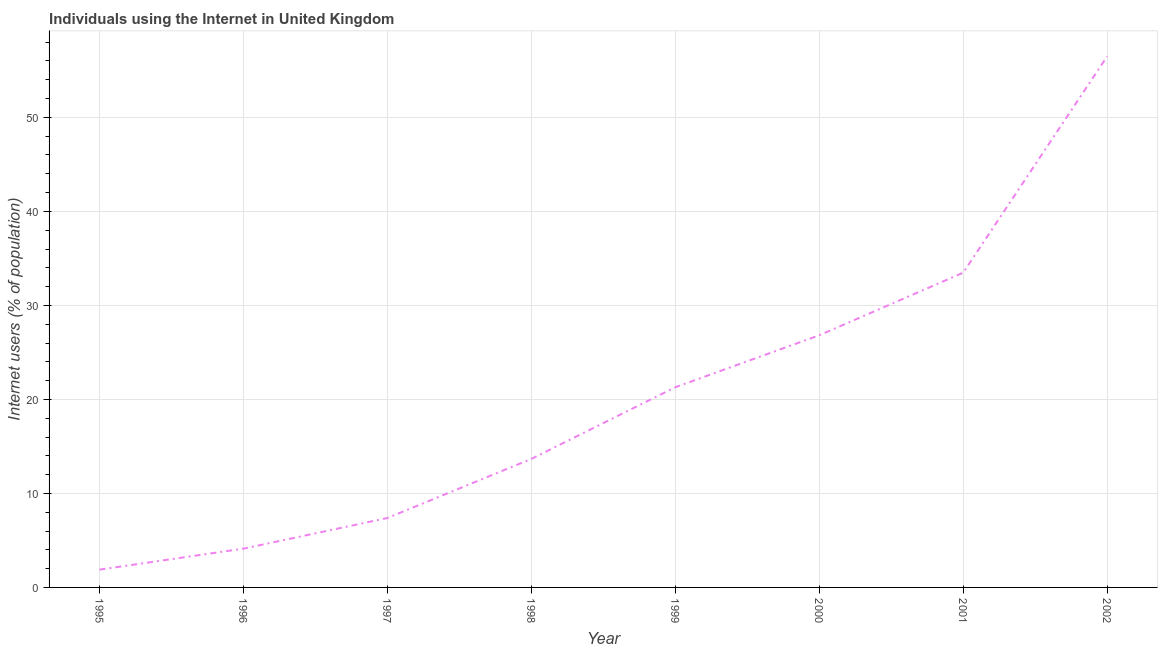What is the number of internet users in 1997?
Provide a succinct answer. 7.39. Across all years, what is the maximum number of internet users?
Give a very brief answer. 56.48. Across all years, what is the minimum number of internet users?
Keep it short and to the point. 1.9. In which year was the number of internet users maximum?
Give a very brief answer. 2002. In which year was the number of internet users minimum?
Offer a terse response. 1995. What is the sum of the number of internet users?
Offer a very short reply. 165.15. What is the difference between the number of internet users in 1996 and 1998?
Make the answer very short. -9.55. What is the average number of internet users per year?
Offer a very short reply. 20.64. What is the median number of internet users?
Your answer should be very brief. 17.48. Do a majority of the years between 1995 and 2000 (inclusive) have number of internet users greater than 52 %?
Offer a terse response. No. What is the ratio of the number of internet users in 1999 to that in 2002?
Your answer should be compact. 0.38. Is the number of internet users in 1997 less than that in 2001?
Provide a succinct answer. Yes. What is the difference between the highest and the second highest number of internet users?
Give a very brief answer. 23. What is the difference between the highest and the lowest number of internet users?
Ensure brevity in your answer.  54.58. In how many years, is the number of internet users greater than the average number of internet users taken over all years?
Your response must be concise. 4. What is the difference between two consecutive major ticks on the Y-axis?
Your response must be concise. 10. Does the graph contain any zero values?
Offer a very short reply. No. What is the title of the graph?
Your answer should be very brief. Individuals using the Internet in United Kingdom. What is the label or title of the X-axis?
Offer a very short reply. Year. What is the label or title of the Y-axis?
Make the answer very short. Internet users (% of population). What is the Internet users (% of population) of 1995?
Offer a very short reply. 1.9. What is the Internet users (% of population) of 1996?
Your response must be concise. 4.12. What is the Internet users (% of population) in 1997?
Give a very brief answer. 7.39. What is the Internet users (% of population) of 1998?
Keep it short and to the point. 13.67. What is the Internet users (% of population) in 1999?
Ensure brevity in your answer.  21.29. What is the Internet users (% of population) of 2000?
Your response must be concise. 26.82. What is the Internet users (% of population) of 2001?
Ensure brevity in your answer.  33.48. What is the Internet users (% of population) of 2002?
Offer a terse response. 56.48. What is the difference between the Internet users (% of population) in 1995 and 1996?
Ensure brevity in your answer.  -2.23. What is the difference between the Internet users (% of population) in 1995 and 1997?
Offer a terse response. -5.49. What is the difference between the Internet users (% of population) in 1995 and 1998?
Provide a short and direct response. -11.77. What is the difference between the Internet users (% of population) in 1995 and 1999?
Make the answer very short. -19.4. What is the difference between the Internet users (% of population) in 1995 and 2000?
Ensure brevity in your answer.  -24.93. What is the difference between the Internet users (% of population) in 1995 and 2001?
Keep it short and to the point. -31.59. What is the difference between the Internet users (% of population) in 1995 and 2002?
Make the answer very short. -54.58. What is the difference between the Internet users (% of population) in 1996 and 1997?
Offer a terse response. -3.26. What is the difference between the Internet users (% of population) in 1996 and 1998?
Provide a short and direct response. -9.55. What is the difference between the Internet users (% of population) in 1996 and 1999?
Your answer should be compact. -17.17. What is the difference between the Internet users (% of population) in 1996 and 2000?
Provide a succinct answer. -22.7. What is the difference between the Internet users (% of population) in 1996 and 2001?
Make the answer very short. -29.36. What is the difference between the Internet users (% of population) in 1996 and 2002?
Provide a short and direct response. -52.36. What is the difference between the Internet users (% of population) in 1997 and 1998?
Offer a very short reply. -6.28. What is the difference between the Internet users (% of population) in 1997 and 1999?
Keep it short and to the point. -13.91. What is the difference between the Internet users (% of population) in 1997 and 2000?
Your answer should be compact. -19.44. What is the difference between the Internet users (% of population) in 1997 and 2001?
Keep it short and to the point. -26.1. What is the difference between the Internet users (% of population) in 1997 and 2002?
Your response must be concise. -49.09. What is the difference between the Internet users (% of population) in 1998 and 1999?
Offer a very short reply. -7.62. What is the difference between the Internet users (% of population) in 1998 and 2000?
Your answer should be compact. -13.15. What is the difference between the Internet users (% of population) in 1998 and 2001?
Offer a very short reply. -19.81. What is the difference between the Internet users (% of population) in 1998 and 2002?
Provide a short and direct response. -42.81. What is the difference between the Internet users (% of population) in 1999 and 2000?
Your answer should be compact. -5.53. What is the difference between the Internet users (% of population) in 1999 and 2001?
Your answer should be very brief. -12.19. What is the difference between the Internet users (% of population) in 1999 and 2002?
Offer a terse response. -35.19. What is the difference between the Internet users (% of population) in 2000 and 2001?
Give a very brief answer. -6.66. What is the difference between the Internet users (% of population) in 2000 and 2002?
Your answer should be compact. -29.66. What is the difference between the Internet users (% of population) in 2001 and 2002?
Keep it short and to the point. -23. What is the ratio of the Internet users (% of population) in 1995 to that in 1996?
Offer a very short reply. 0.46. What is the ratio of the Internet users (% of population) in 1995 to that in 1997?
Your response must be concise. 0.26. What is the ratio of the Internet users (% of population) in 1995 to that in 1998?
Provide a short and direct response. 0.14. What is the ratio of the Internet users (% of population) in 1995 to that in 1999?
Your answer should be very brief. 0.09. What is the ratio of the Internet users (% of population) in 1995 to that in 2000?
Ensure brevity in your answer.  0.07. What is the ratio of the Internet users (% of population) in 1995 to that in 2001?
Make the answer very short. 0.06. What is the ratio of the Internet users (% of population) in 1995 to that in 2002?
Offer a terse response. 0.03. What is the ratio of the Internet users (% of population) in 1996 to that in 1997?
Make the answer very short. 0.56. What is the ratio of the Internet users (% of population) in 1996 to that in 1998?
Keep it short and to the point. 0.3. What is the ratio of the Internet users (% of population) in 1996 to that in 1999?
Offer a terse response. 0.19. What is the ratio of the Internet users (% of population) in 1996 to that in 2000?
Your answer should be very brief. 0.15. What is the ratio of the Internet users (% of population) in 1996 to that in 2001?
Your answer should be compact. 0.12. What is the ratio of the Internet users (% of population) in 1996 to that in 2002?
Offer a terse response. 0.07. What is the ratio of the Internet users (% of population) in 1997 to that in 1998?
Keep it short and to the point. 0.54. What is the ratio of the Internet users (% of population) in 1997 to that in 1999?
Offer a terse response. 0.35. What is the ratio of the Internet users (% of population) in 1997 to that in 2000?
Offer a very short reply. 0.28. What is the ratio of the Internet users (% of population) in 1997 to that in 2001?
Your response must be concise. 0.22. What is the ratio of the Internet users (% of population) in 1997 to that in 2002?
Offer a terse response. 0.13. What is the ratio of the Internet users (% of population) in 1998 to that in 1999?
Give a very brief answer. 0.64. What is the ratio of the Internet users (% of population) in 1998 to that in 2000?
Give a very brief answer. 0.51. What is the ratio of the Internet users (% of population) in 1998 to that in 2001?
Your answer should be compact. 0.41. What is the ratio of the Internet users (% of population) in 1998 to that in 2002?
Offer a terse response. 0.24. What is the ratio of the Internet users (% of population) in 1999 to that in 2000?
Your answer should be compact. 0.79. What is the ratio of the Internet users (% of population) in 1999 to that in 2001?
Offer a terse response. 0.64. What is the ratio of the Internet users (% of population) in 1999 to that in 2002?
Offer a very short reply. 0.38. What is the ratio of the Internet users (% of population) in 2000 to that in 2001?
Provide a short and direct response. 0.8. What is the ratio of the Internet users (% of population) in 2000 to that in 2002?
Provide a succinct answer. 0.47. What is the ratio of the Internet users (% of population) in 2001 to that in 2002?
Provide a short and direct response. 0.59. 